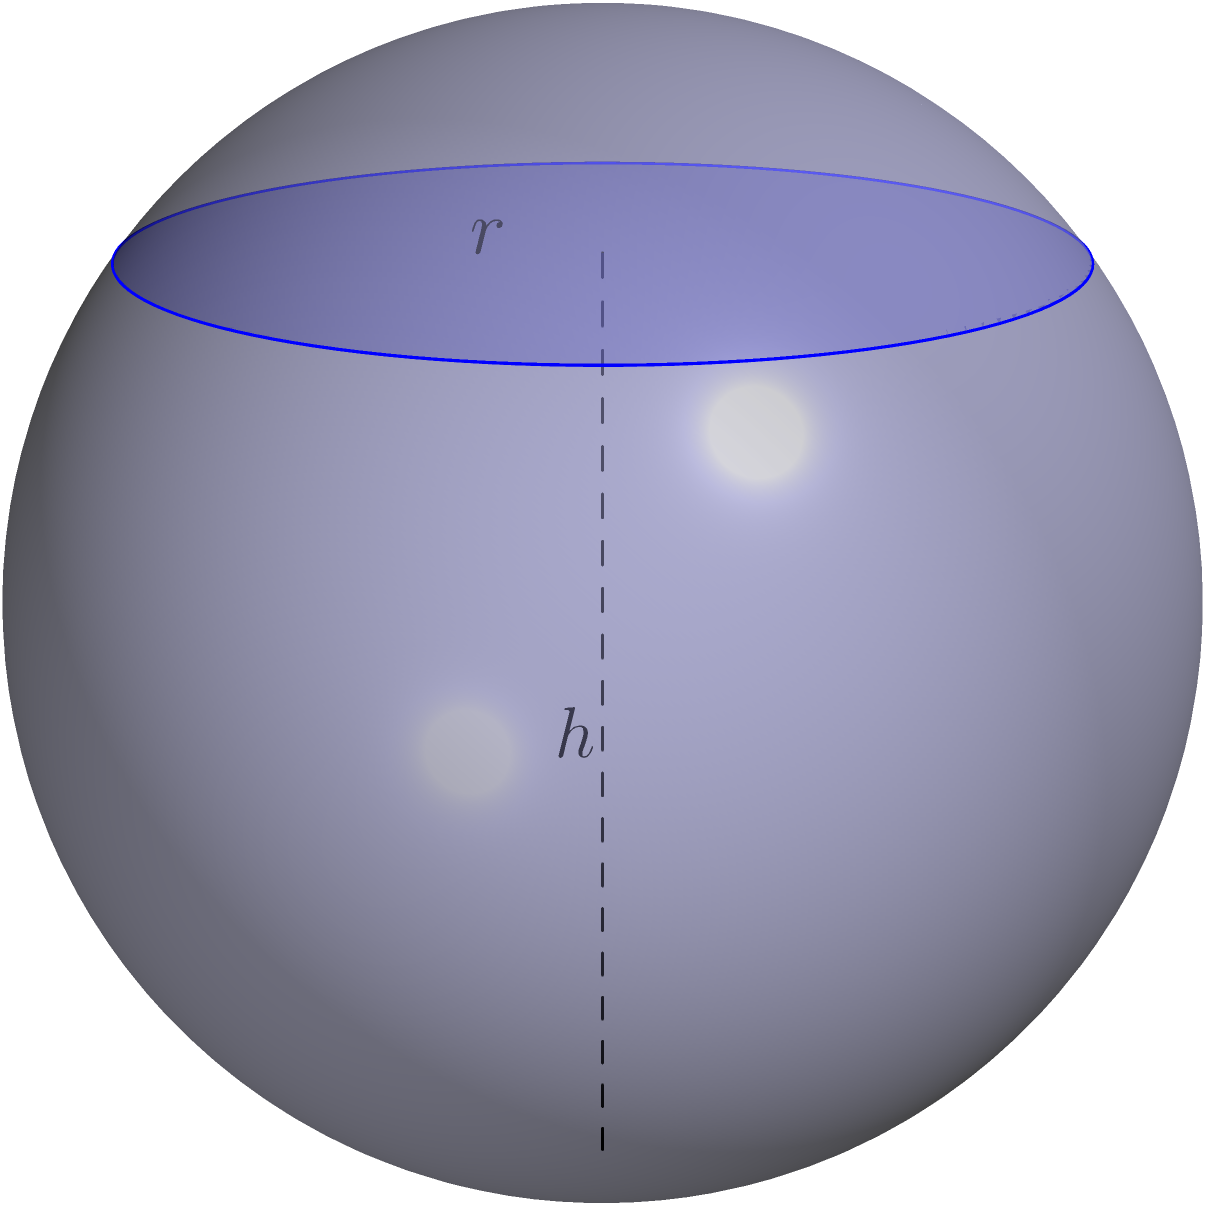In your luxury expatriate housing complex in South Jakarta, there's a unique spherical swimming pool with a radius of 5 meters. If the pool is filled with water to a height of 3 meters from the bottom, what is the volume of water in the pool? (Use $\pi = 3.14$ for calculations) To solve this problem, we need to use the formula for the volume of a spherical segment:

$$V = \frac{\pi h^2}{3}(3R - h)$$

Where:
$V$ is the volume of the spherical segment
$h$ is the height of the water
$R$ is the radius of the sphere

Given:
$R = 5$ meters
$h = 3$ meters
$\pi = 3.14$

Let's substitute these values into the formula:

$$V = \frac{3.14 \times 3^2}{3}(3 \times 5 - 3)$$

Simplifying:
$$V = \frac{3.14 \times 9}{3}(15 - 3)$$
$$V = 9.42 \times 12$$
$$V = 113.04$$

Therefore, the volume of water in the pool is approximately 113.04 cubic meters.
Answer: 113.04 cubic meters 